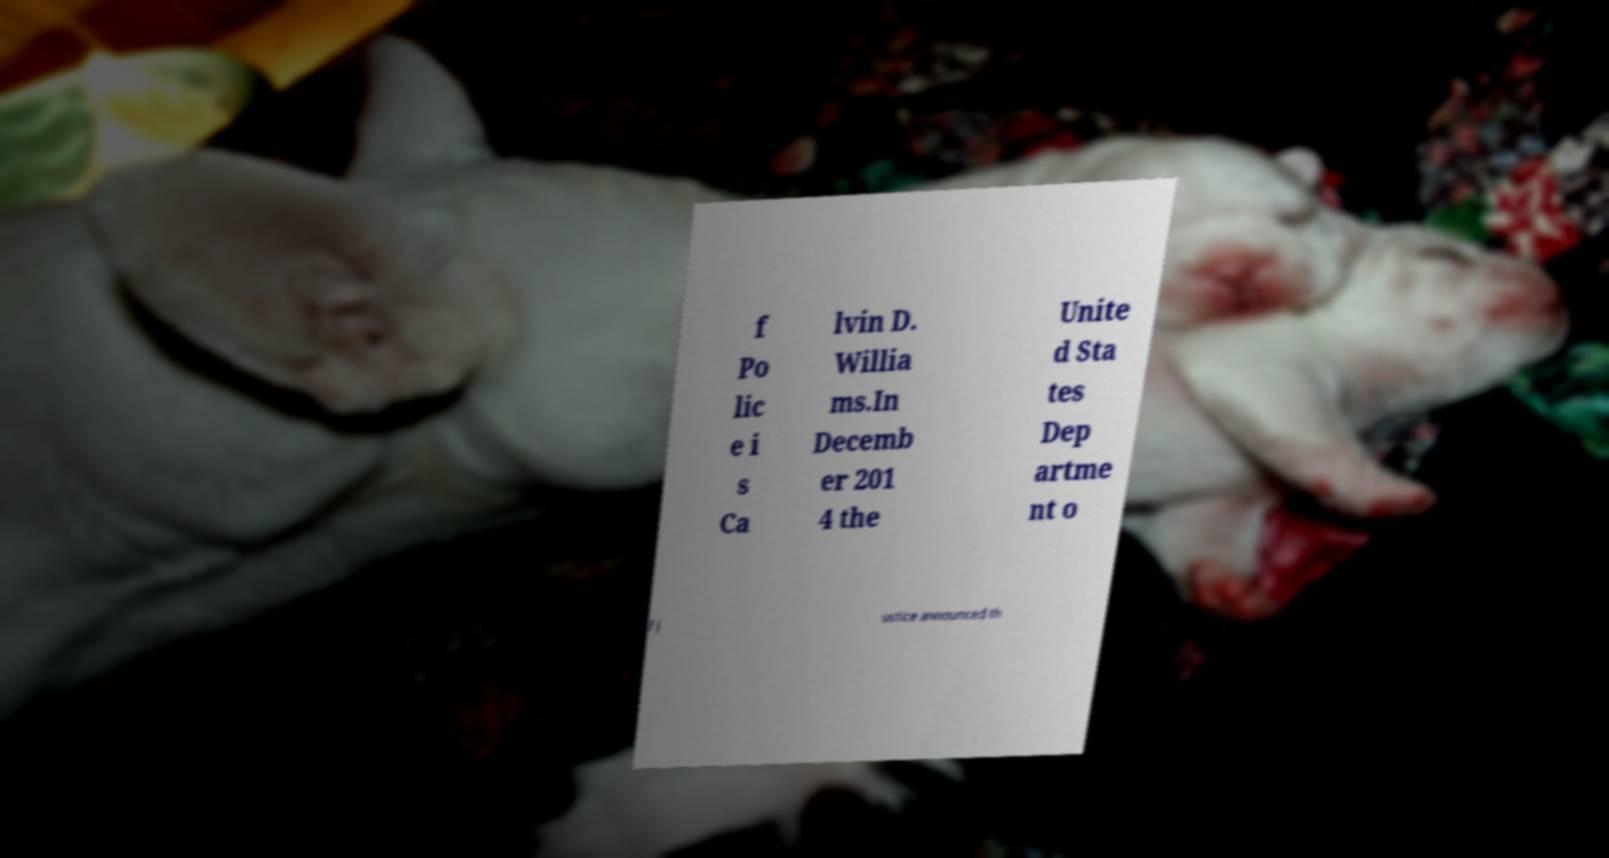Please identify and transcribe the text found in this image. f Po lic e i s Ca lvin D. Willia ms.In Decemb er 201 4 the Unite d Sta tes Dep artme nt o f J ustice announced th 